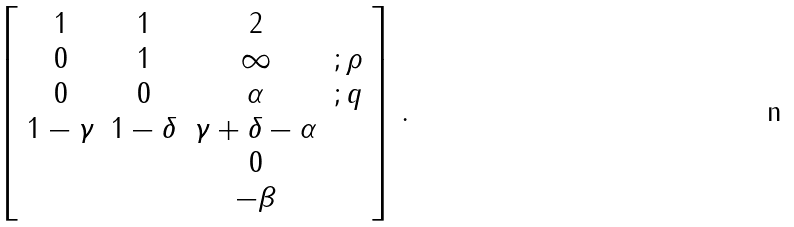Convert formula to latex. <formula><loc_0><loc_0><loc_500><loc_500>\left [ \begin{array} { c c c c } 1 & 1 & 2 & \\ 0 & 1 & \infty & ; \rho \\ 0 & 0 & \alpha & ; q \\ 1 - \gamma & 1 - \delta & \gamma + \delta - \alpha & \\ & & 0 & \\ & & - \beta & \\ \end{array} \right ] \, .</formula> 